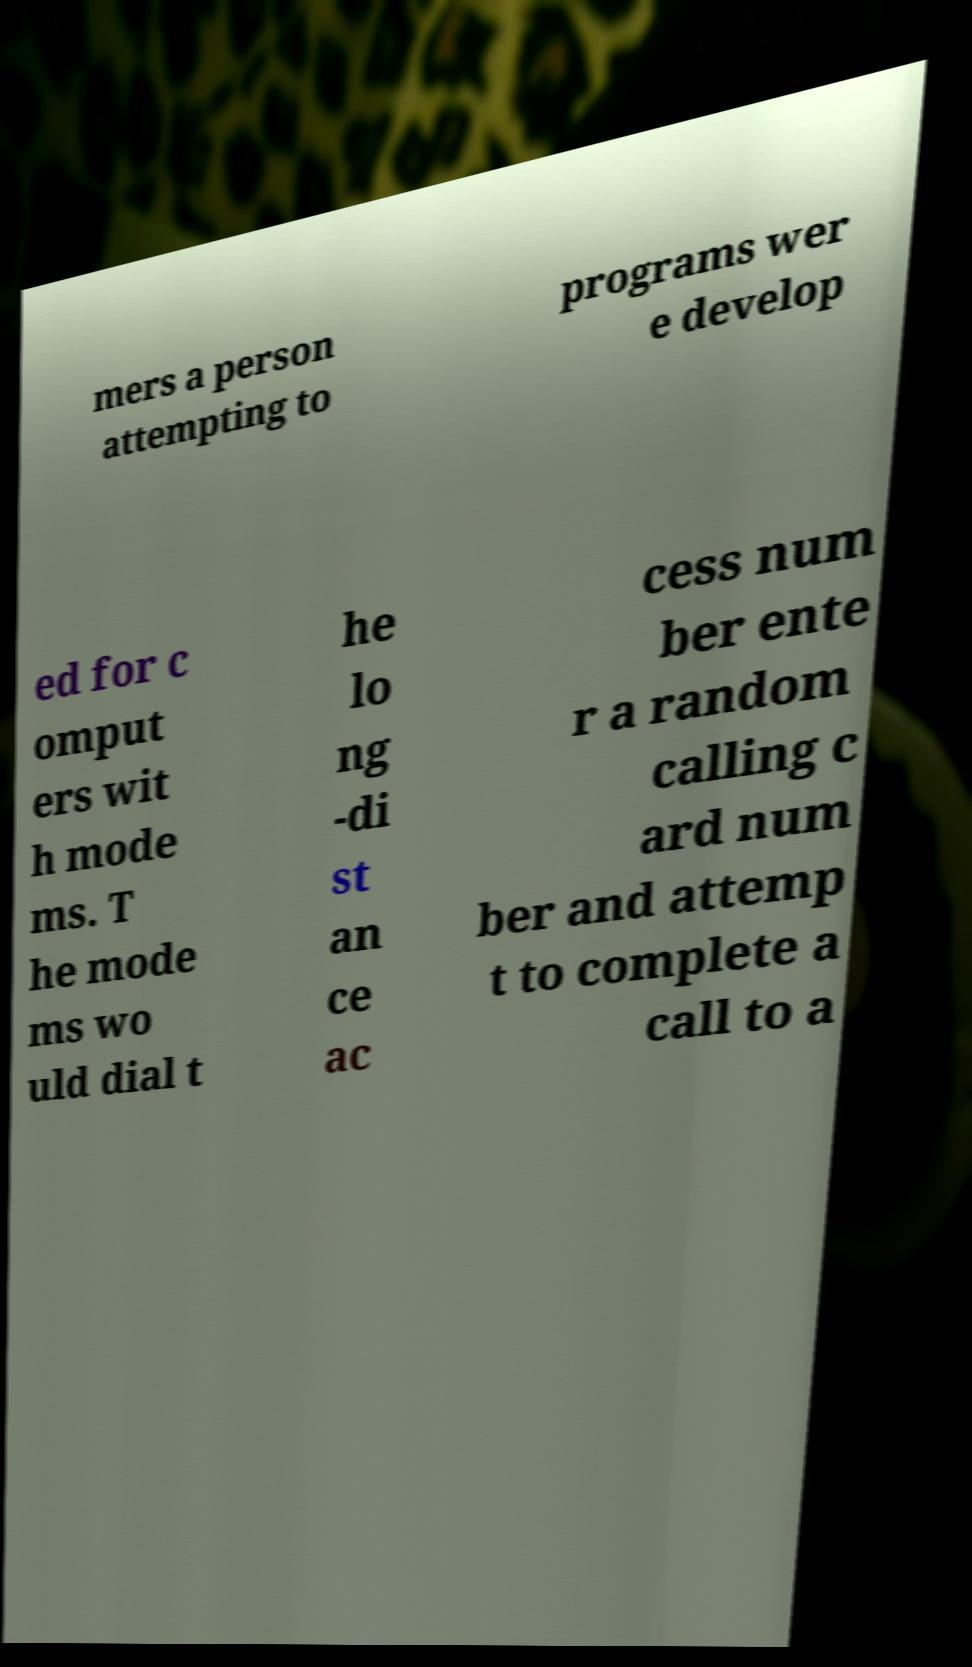Can you accurately transcribe the text from the provided image for me? mers a person attempting to programs wer e develop ed for c omput ers wit h mode ms. T he mode ms wo uld dial t he lo ng -di st an ce ac cess num ber ente r a random calling c ard num ber and attemp t to complete a call to a 